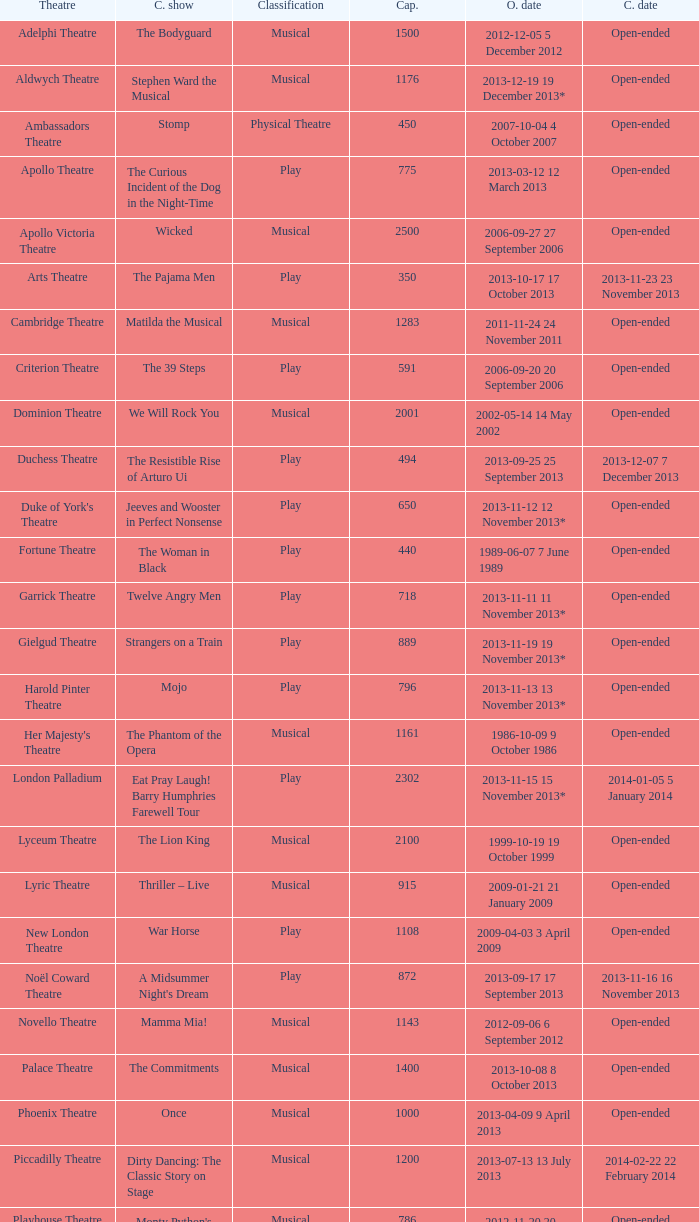What is the opening date of the musical at the adelphi theatre? 2012-12-05 5 December 2012. 